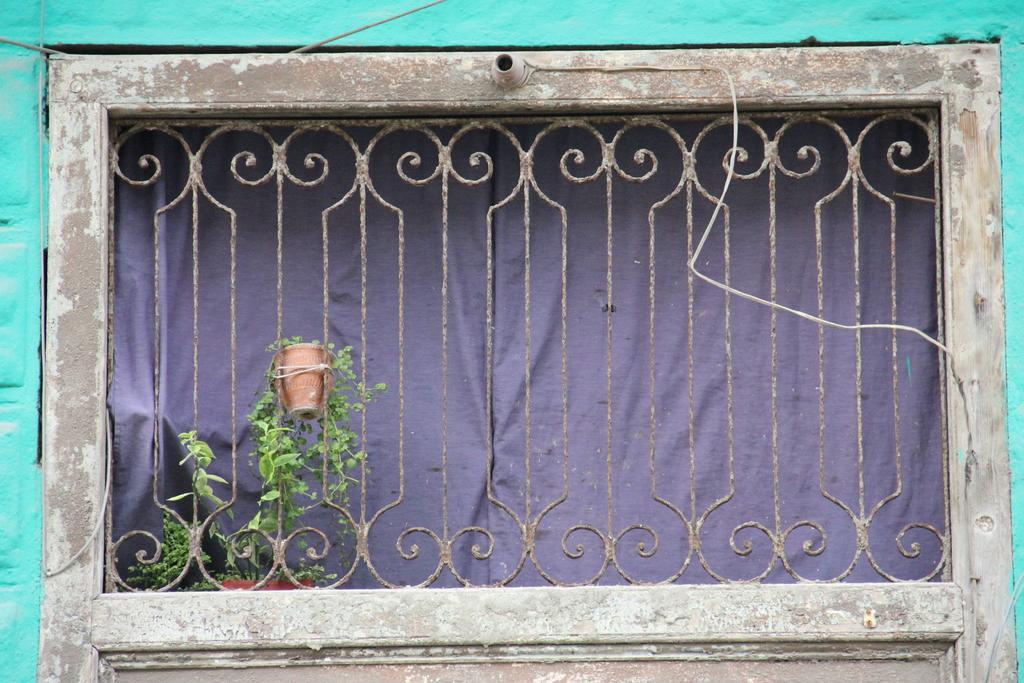Could you give a brief overview of what you see in this image? In this image we can see a grille, a potted plant attached to the grille, there is a light holder attached to the wood and there is curtain behind the grille. 